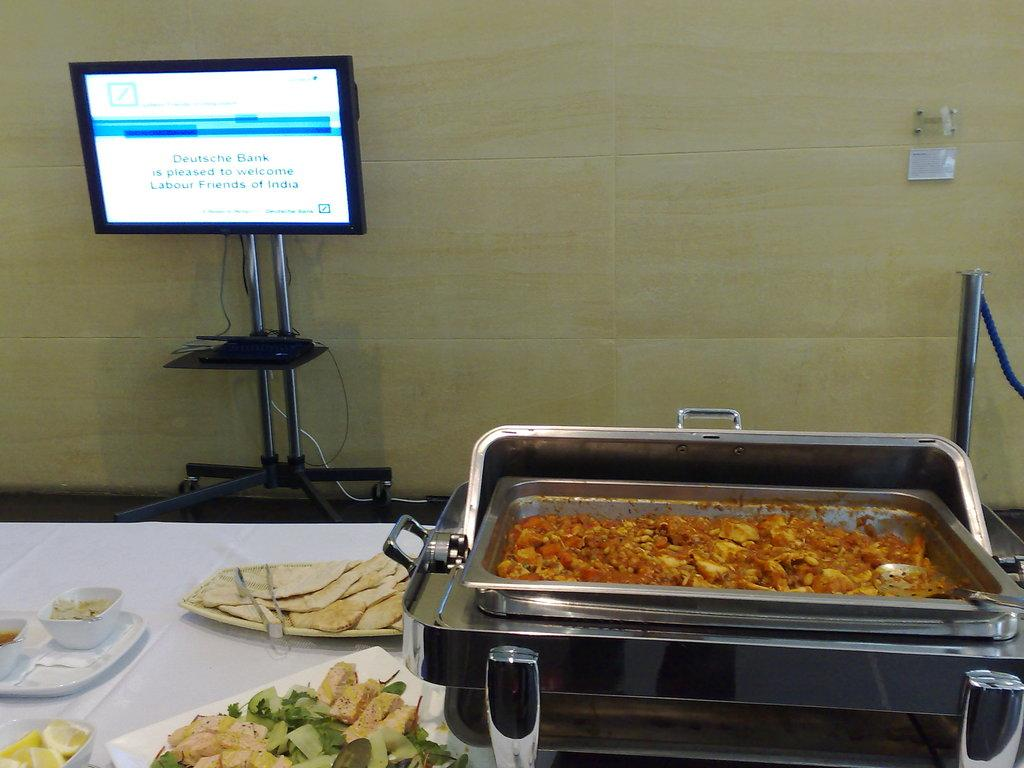<image>
Describe the image concisely. A table of food and a computer screen with a message from Deutsche Bank welcoming the Labour Friends of India. 